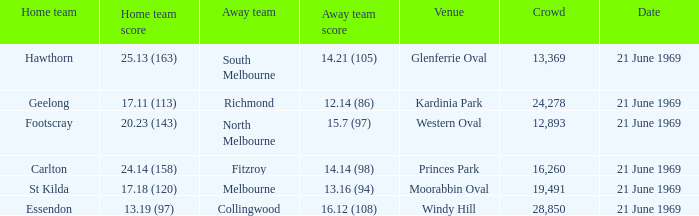For essendon's home team, which one has an away crowd size exceeding 19,491? Collingwood. 